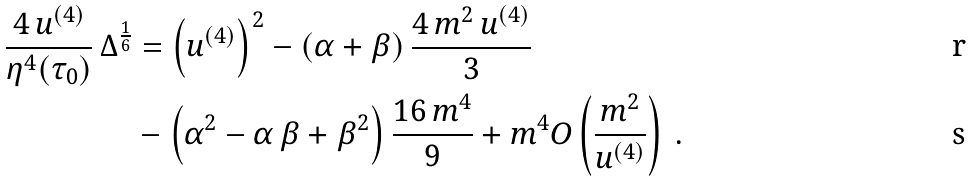<formula> <loc_0><loc_0><loc_500><loc_500>\frac { 4 \, u ^ { ( 4 ) } } { \eta ^ { 4 } ( \tau _ { 0 } ) } \, \Delta ^ { \frac { 1 } { 6 } } & = \left ( u ^ { ( 4 ) } \right ) ^ { 2 } - \left ( \alpha + \beta \right ) \frac { 4 \, m ^ { 2 } \, u ^ { ( 4 ) } } { 3 } \\ & - \left ( \alpha ^ { 2 } - \alpha \, \beta + \beta ^ { 2 } \right ) \frac { 1 6 \, m ^ { 4 } } { 9 } + m ^ { 4 } O \left ( \frac { m ^ { 2 } } { u ^ { ( 4 ) } } \right ) \, .</formula> 